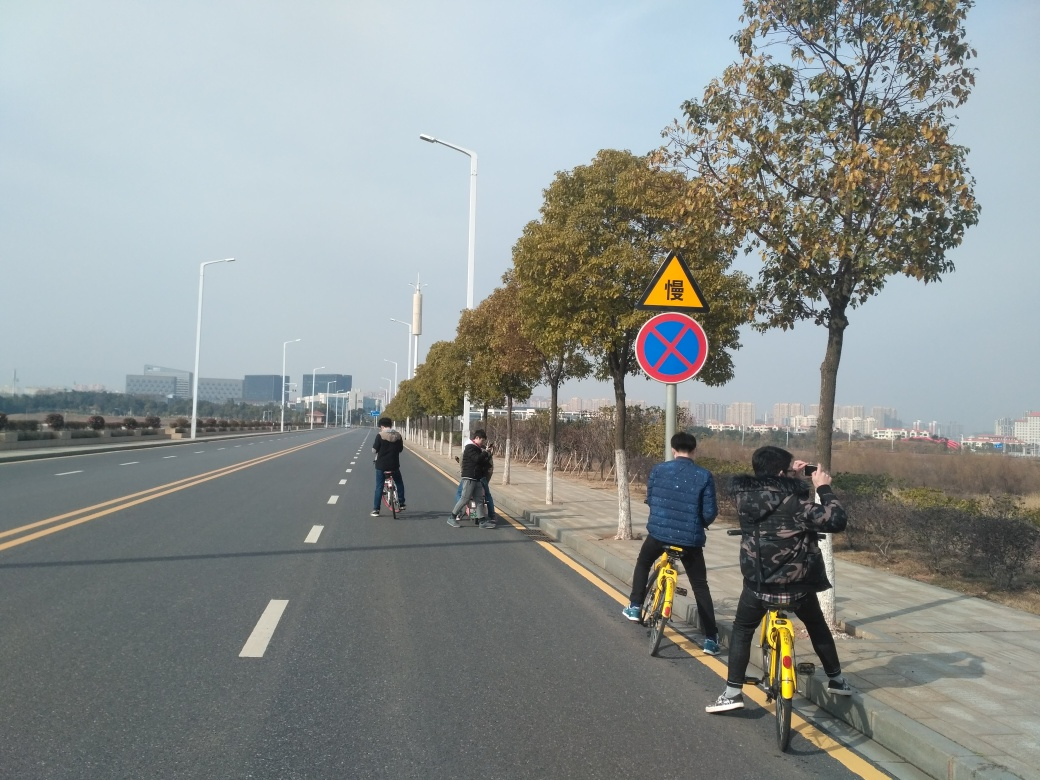What might be the purpose of the person’s activity to the right of the image? The person on the right appears to be taking a photograph. This individual might be capturing the scenery, documenting the travel experience, or taking a photo of the companions riding bicycles. Photography can serve various purposes such as personal mementos, artistic expression, or social sharing. 